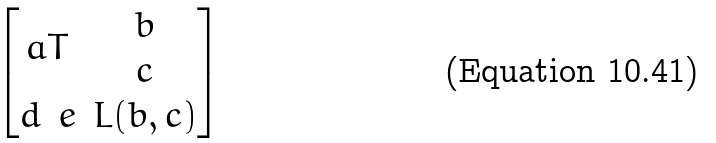<formula> <loc_0><loc_0><loc_500><loc_500>\begin{bmatrix} a T & \begin{matrix} b \\ c \end{matrix} \\ \begin{matrix} d & e \end{matrix} & L ( b , c ) \end{bmatrix}</formula> 